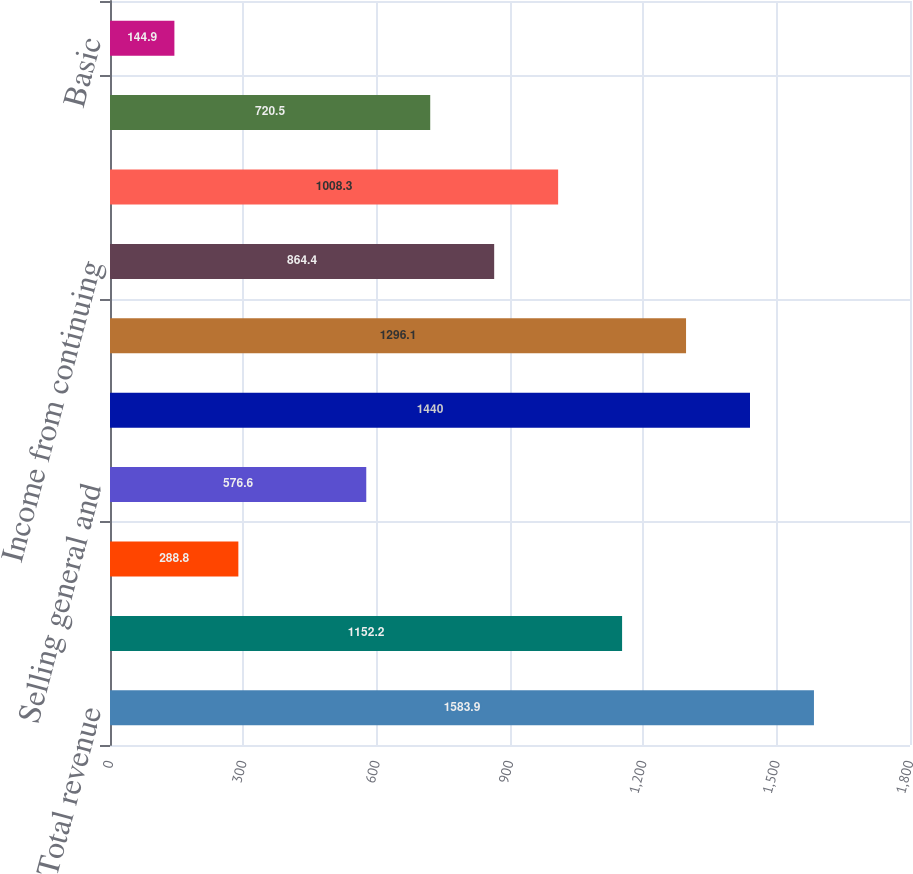<chart> <loc_0><loc_0><loc_500><loc_500><bar_chart><fcel>Total revenue<fcel>Cost of processing and<fcel>Cost of product<fcel>Selling general and<fcel>Total expenses<fcel>Operating income<fcel>Income from continuing<fcel>Net income<fcel>Comprehensive income<fcel>Basic<nl><fcel>1583.9<fcel>1152.2<fcel>288.8<fcel>576.6<fcel>1440<fcel>1296.1<fcel>864.4<fcel>1008.3<fcel>720.5<fcel>144.9<nl></chart> 